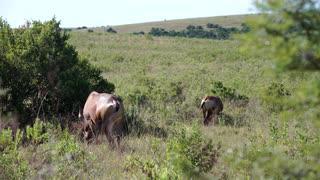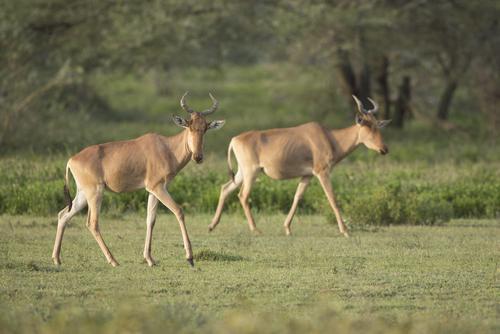The first image is the image on the left, the second image is the image on the right. Analyze the images presented: Is the assertion "There are two antelope together in the right image." valid? Answer yes or no. Yes. 